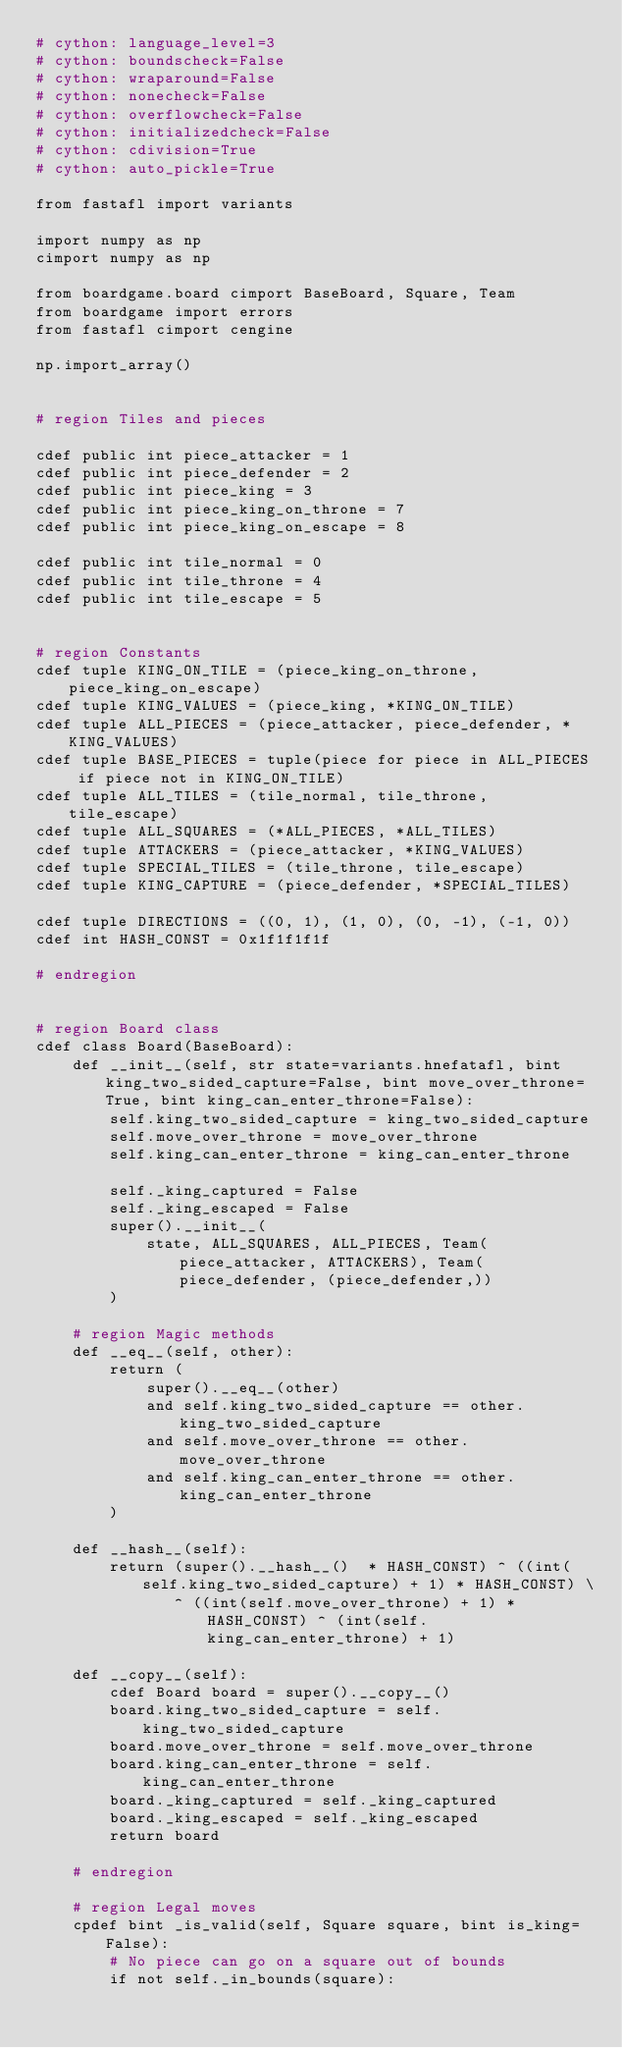<code> <loc_0><loc_0><loc_500><loc_500><_Cython_># cython: language_level=3
# cython: boundscheck=False
# cython: wraparound=False
# cython: nonecheck=False
# cython: overflowcheck=False
# cython: initializedcheck=False
# cython: cdivision=True
# cython: auto_pickle=True

from fastafl import variants

import numpy as np
cimport numpy as np

from boardgame.board cimport BaseBoard, Square, Team
from boardgame import errors
from fastafl cimport cengine

np.import_array()


# region Tiles and pieces

cdef public int piece_attacker = 1
cdef public int piece_defender = 2
cdef public int piece_king = 3
cdef public int piece_king_on_throne = 7
cdef public int piece_king_on_escape = 8

cdef public int tile_normal = 0
cdef public int tile_throne = 4
cdef public int tile_escape = 5


# region Constants
cdef tuple KING_ON_TILE = (piece_king_on_throne, piece_king_on_escape)
cdef tuple KING_VALUES = (piece_king, *KING_ON_TILE)
cdef tuple ALL_PIECES = (piece_attacker, piece_defender, *KING_VALUES)
cdef tuple BASE_PIECES = tuple(piece for piece in ALL_PIECES if piece not in KING_ON_TILE)
cdef tuple ALL_TILES = (tile_normal, tile_throne, tile_escape)
cdef tuple ALL_SQUARES = (*ALL_PIECES, *ALL_TILES)
cdef tuple ATTACKERS = (piece_attacker, *KING_VALUES)
cdef tuple SPECIAL_TILES = (tile_throne, tile_escape)
cdef tuple KING_CAPTURE = (piece_defender, *SPECIAL_TILES)

cdef tuple DIRECTIONS = ((0, 1), (1, 0), (0, -1), (-1, 0))
cdef int HASH_CONST = 0x1f1f1f1f

# endregion


# region Board class
cdef class Board(BaseBoard):
    def __init__(self, str state=variants.hnefatafl, bint king_two_sided_capture=False, bint move_over_throne=True, bint king_can_enter_throne=False):
        self.king_two_sided_capture = king_two_sided_capture
        self.move_over_throne = move_over_throne
        self.king_can_enter_throne = king_can_enter_throne

        self._king_captured = False
        self._king_escaped = False
        super().__init__(
            state, ALL_SQUARES, ALL_PIECES, Team(piece_attacker, ATTACKERS), Team(piece_defender, (piece_defender,))
        )

    # region Magic methods
    def __eq__(self, other):
        return (
            super().__eq__(other)
            and self.king_two_sided_capture == other.king_two_sided_capture
            and self.move_over_throne == other.move_over_throne
            and self.king_can_enter_throne == other.king_can_enter_throne
        )

    def __hash__(self):
        return (super().__hash__()  * HASH_CONST) ^ ((int(self.king_two_sided_capture) + 1) * HASH_CONST) \
               ^ ((int(self.move_over_throne) + 1) * HASH_CONST) ^ (int(self.king_can_enter_throne) + 1)

    def __copy__(self):
        cdef Board board = super().__copy__()
        board.king_two_sided_capture = self.king_two_sided_capture
        board.move_over_throne = self.move_over_throne
        board.king_can_enter_throne = self.king_can_enter_throne
        board._king_captured = self._king_captured
        board._king_escaped = self._king_escaped
        return board

    # endregion

    # region Legal moves
    cpdef bint _is_valid(self, Square square, bint is_king=False):
        # No piece can go on a square out of bounds
        if not self._in_bounds(square):</code> 